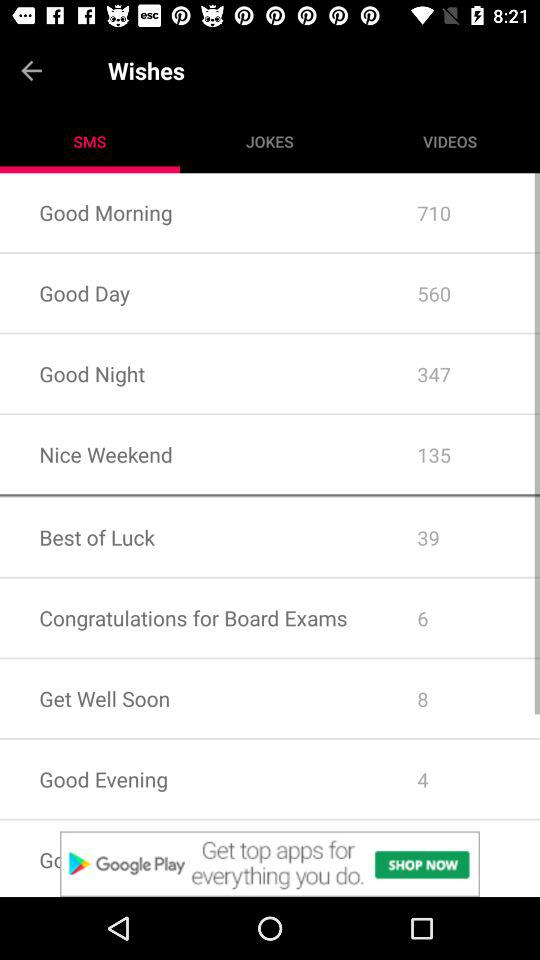How many wishes are there for "Nice Weekend"? There are 135 wishes for "Nice Weekend". 